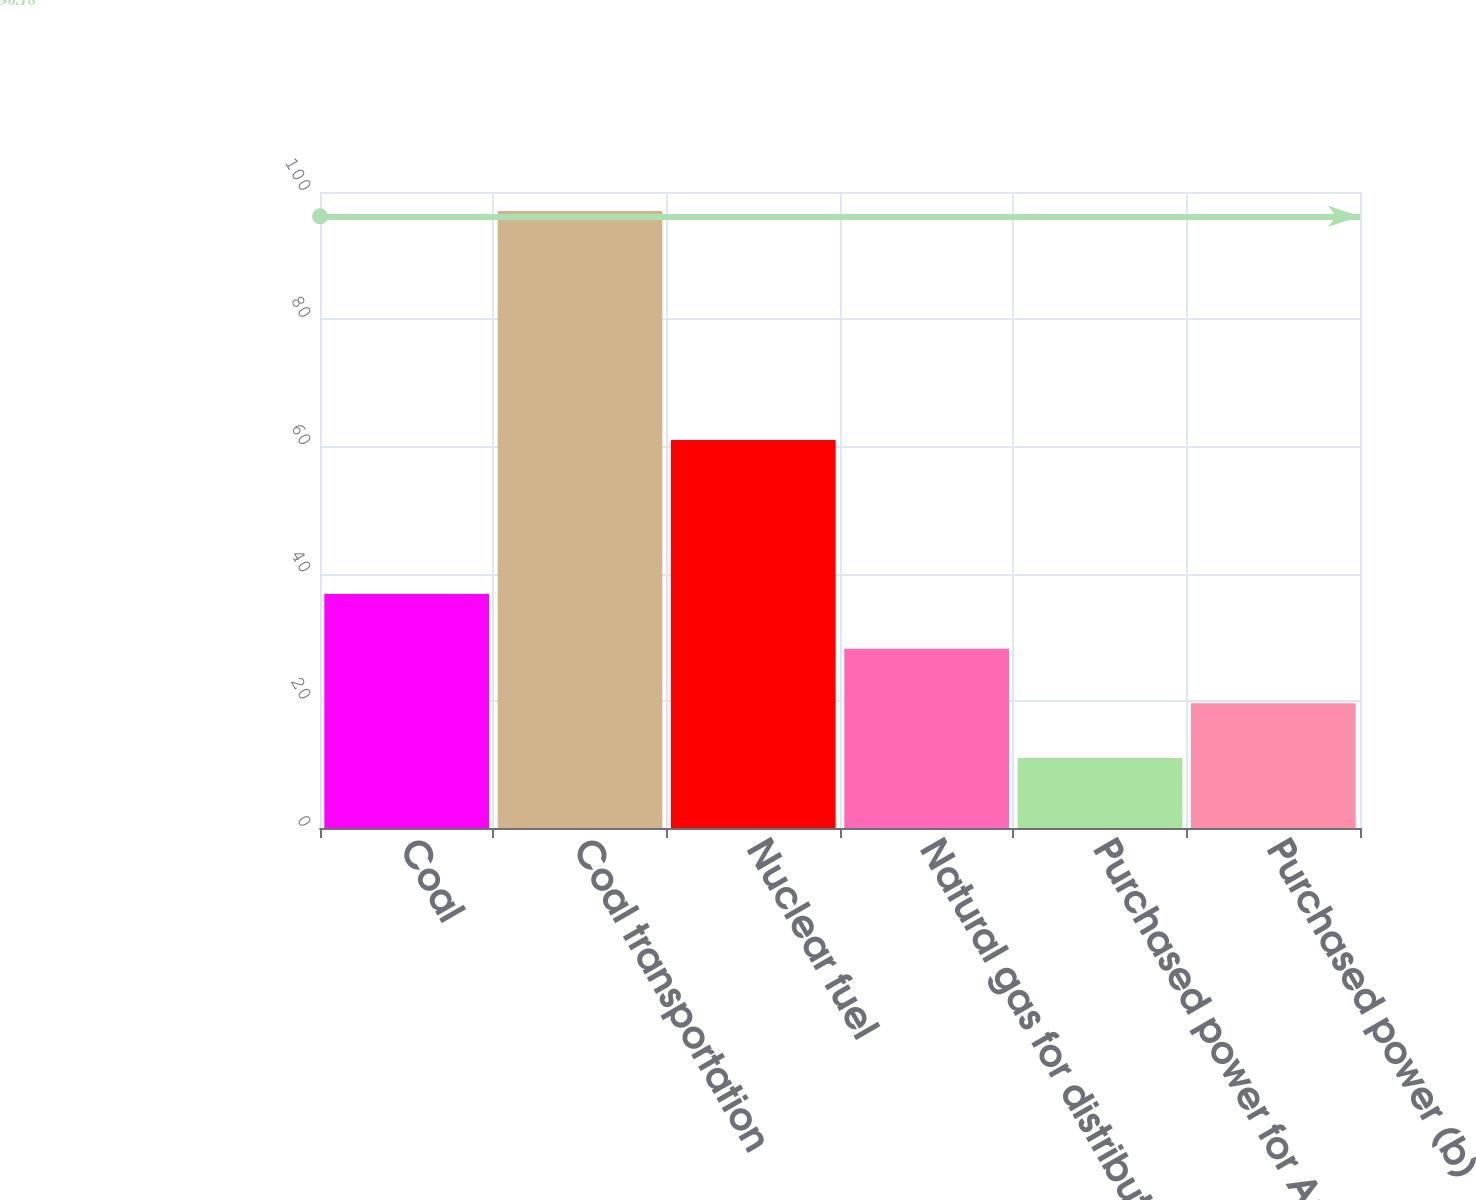<chart> <loc_0><loc_0><loc_500><loc_500><bar_chart><fcel>Coal<fcel>Coal transportation<fcel>Nuclear fuel<fcel>Natural gas for distribution<fcel>Purchased power for Ameren<fcel>Purchased power (b)<nl><fcel>36.8<fcel>97<fcel>61<fcel>28.2<fcel>11<fcel>19.6<nl></chart> 